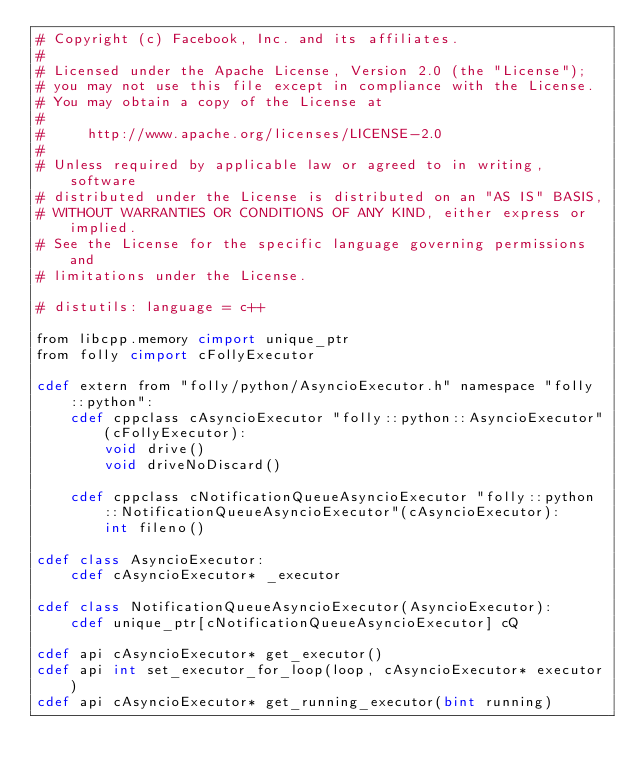<code> <loc_0><loc_0><loc_500><loc_500><_Cython_># Copyright (c) Facebook, Inc. and its affiliates.
#
# Licensed under the Apache License, Version 2.0 (the "License");
# you may not use this file except in compliance with the License.
# You may obtain a copy of the License at
#
#     http://www.apache.org/licenses/LICENSE-2.0
#
# Unless required by applicable law or agreed to in writing, software
# distributed under the License is distributed on an "AS IS" BASIS,
# WITHOUT WARRANTIES OR CONDITIONS OF ANY KIND, either express or implied.
# See the License for the specific language governing permissions and
# limitations under the License.

# distutils: language = c++

from libcpp.memory cimport unique_ptr
from folly cimport cFollyExecutor

cdef extern from "folly/python/AsyncioExecutor.h" namespace "folly::python":
    cdef cppclass cAsyncioExecutor "folly::python::AsyncioExecutor"(cFollyExecutor):
        void drive()
        void driveNoDiscard()

    cdef cppclass cNotificationQueueAsyncioExecutor "folly::python::NotificationQueueAsyncioExecutor"(cAsyncioExecutor):
        int fileno()

cdef class AsyncioExecutor:
    cdef cAsyncioExecutor* _executor

cdef class NotificationQueueAsyncioExecutor(AsyncioExecutor):
    cdef unique_ptr[cNotificationQueueAsyncioExecutor] cQ

cdef api cAsyncioExecutor* get_executor()
cdef api int set_executor_for_loop(loop, cAsyncioExecutor* executor)
cdef api cAsyncioExecutor* get_running_executor(bint running)
</code> 